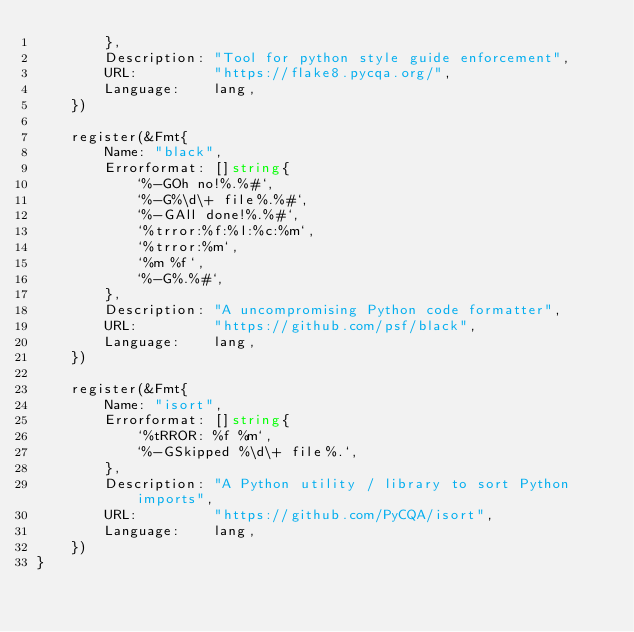Convert code to text. <code><loc_0><loc_0><loc_500><loc_500><_Go_>		},
		Description: "Tool for python style guide enforcement",
		URL:         "https://flake8.pycqa.org/",
		Language:    lang,
	})

	register(&Fmt{
		Name: "black",
		Errorformat: []string{
			`%-GOh no!%.%#`,
			`%-G%\d\+ file%.%#`,
			`%-GAll done!%.%#`,
			`%trror:%f:%l:%c:%m`,
			`%trror:%m`,
			`%m %f`,
			`%-G%.%#`,
		},
		Description: "A uncompromising Python code formatter",
		URL:         "https://github.com/psf/black",
		Language:    lang,
	})

	register(&Fmt{
		Name: "isort",
		Errorformat: []string{
			`%tRROR: %f %m`,
			`%-GSkipped %\d\+ file%.`,
		},
		Description: "A Python utility / library to sort Python imports",
		URL:         "https://github.com/PyCQA/isort",
		Language:    lang,
	})
}
</code> 